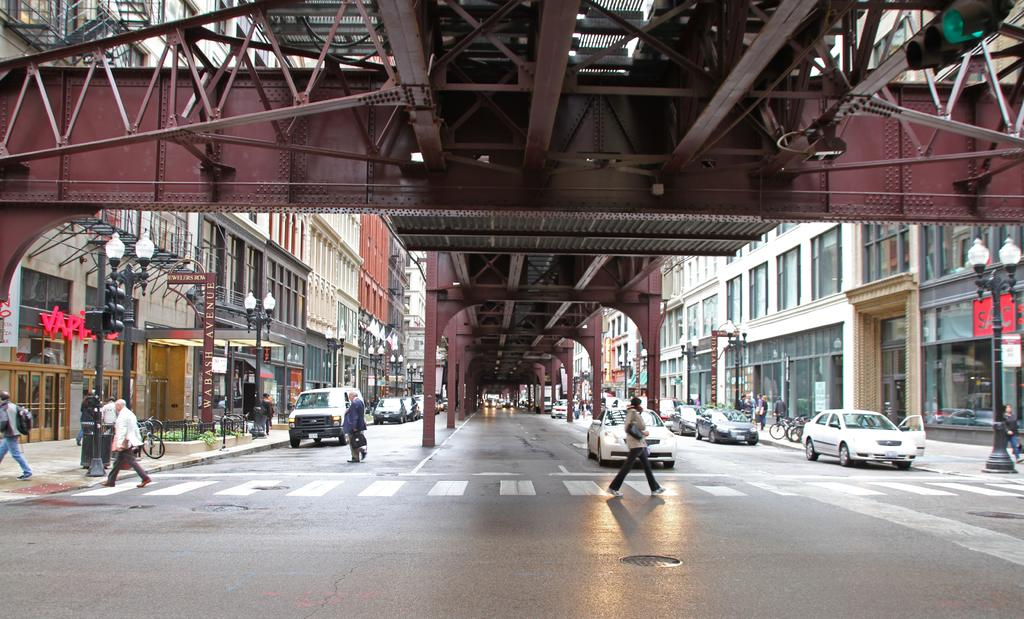<image>
Relay a brief, clear account of the picture shown. a crosswalk underneath a bridge next to a building sign that says 'SAC' 